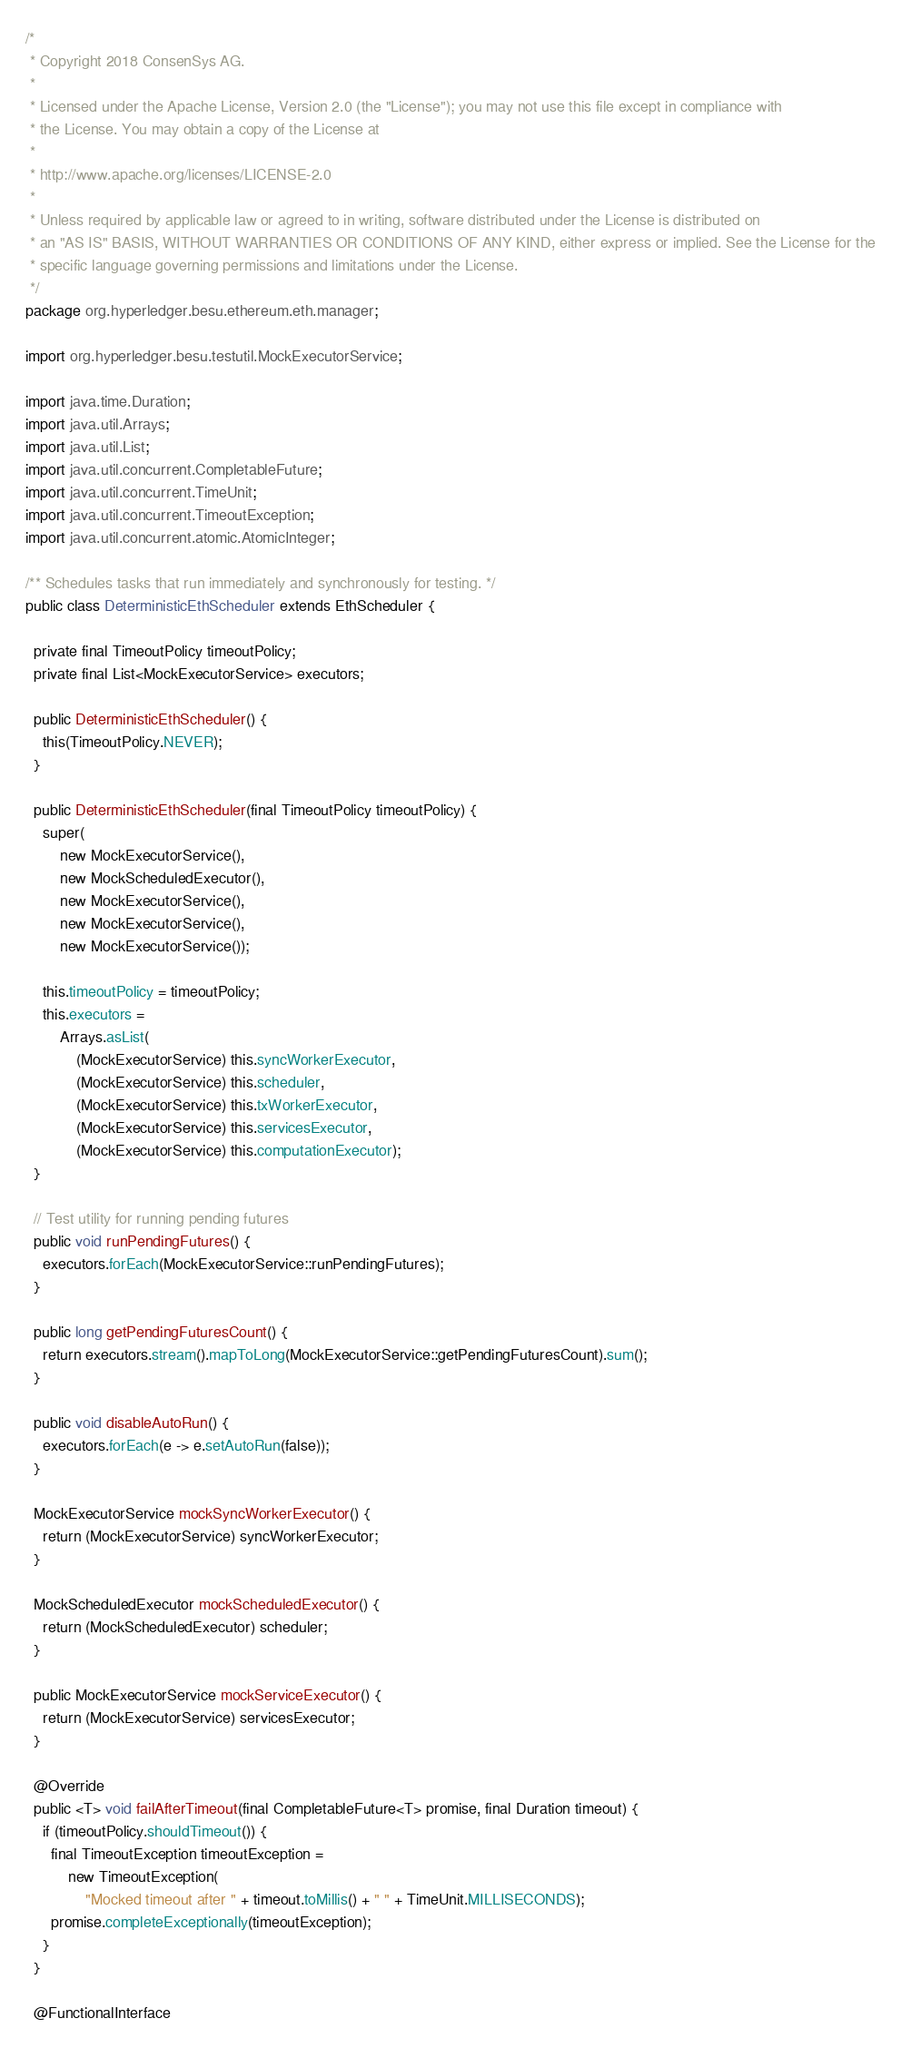Convert code to text. <code><loc_0><loc_0><loc_500><loc_500><_Java_>/*
 * Copyright 2018 ConsenSys AG.
 *
 * Licensed under the Apache License, Version 2.0 (the "License"); you may not use this file except in compliance with
 * the License. You may obtain a copy of the License at
 *
 * http://www.apache.org/licenses/LICENSE-2.0
 *
 * Unless required by applicable law or agreed to in writing, software distributed under the License is distributed on
 * an "AS IS" BASIS, WITHOUT WARRANTIES OR CONDITIONS OF ANY KIND, either express or implied. See the License for the
 * specific language governing permissions and limitations under the License.
 */
package org.hyperledger.besu.ethereum.eth.manager;

import org.hyperledger.besu.testutil.MockExecutorService;

import java.time.Duration;
import java.util.Arrays;
import java.util.List;
import java.util.concurrent.CompletableFuture;
import java.util.concurrent.TimeUnit;
import java.util.concurrent.TimeoutException;
import java.util.concurrent.atomic.AtomicInteger;

/** Schedules tasks that run immediately and synchronously for testing. */
public class DeterministicEthScheduler extends EthScheduler {

  private final TimeoutPolicy timeoutPolicy;
  private final List<MockExecutorService> executors;

  public DeterministicEthScheduler() {
    this(TimeoutPolicy.NEVER);
  }

  public DeterministicEthScheduler(final TimeoutPolicy timeoutPolicy) {
    super(
        new MockExecutorService(),
        new MockScheduledExecutor(),
        new MockExecutorService(),
        new MockExecutorService(),
        new MockExecutorService());

    this.timeoutPolicy = timeoutPolicy;
    this.executors =
        Arrays.asList(
            (MockExecutorService) this.syncWorkerExecutor,
            (MockExecutorService) this.scheduler,
            (MockExecutorService) this.txWorkerExecutor,
            (MockExecutorService) this.servicesExecutor,
            (MockExecutorService) this.computationExecutor);
  }

  // Test utility for running pending futures
  public void runPendingFutures() {
    executors.forEach(MockExecutorService::runPendingFutures);
  }

  public long getPendingFuturesCount() {
    return executors.stream().mapToLong(MockExecutorService::getPendingFuturesCount).sum();
  }

  public void disableAutoRun() {
    executors.forEach(e -> e.setAutoRun(false));
  }

  MockExecutorService mockSyncWorkerExecutor() {
    return (MockExecutorService) syncWorkerExecutor;
  }

  MockScheduledExecutor mockScheduledExecutor() {
    return (MockScheduledExecutor) scheduler;
  }

  public MockExecutorService mockServiceExecutor() {
    return (MockExecutorService) servicesExecutor;
  }

  @Override
  public <T> void failAfterTimeout(final CompletableFuture<T> promise, final Duration timeout) {
    if (timeoutPolicy.shouldTimeout()) {
      final TimeoutException timeoutException =
          new TimeoutException(
              "Mocked timeout after " + timeout.toMillis() + " " + TimeUnit.MILLISECONDS);
      promise.completeExceptionally(timeoutException);
    }
  }

  @FunctionalInterface</code> 